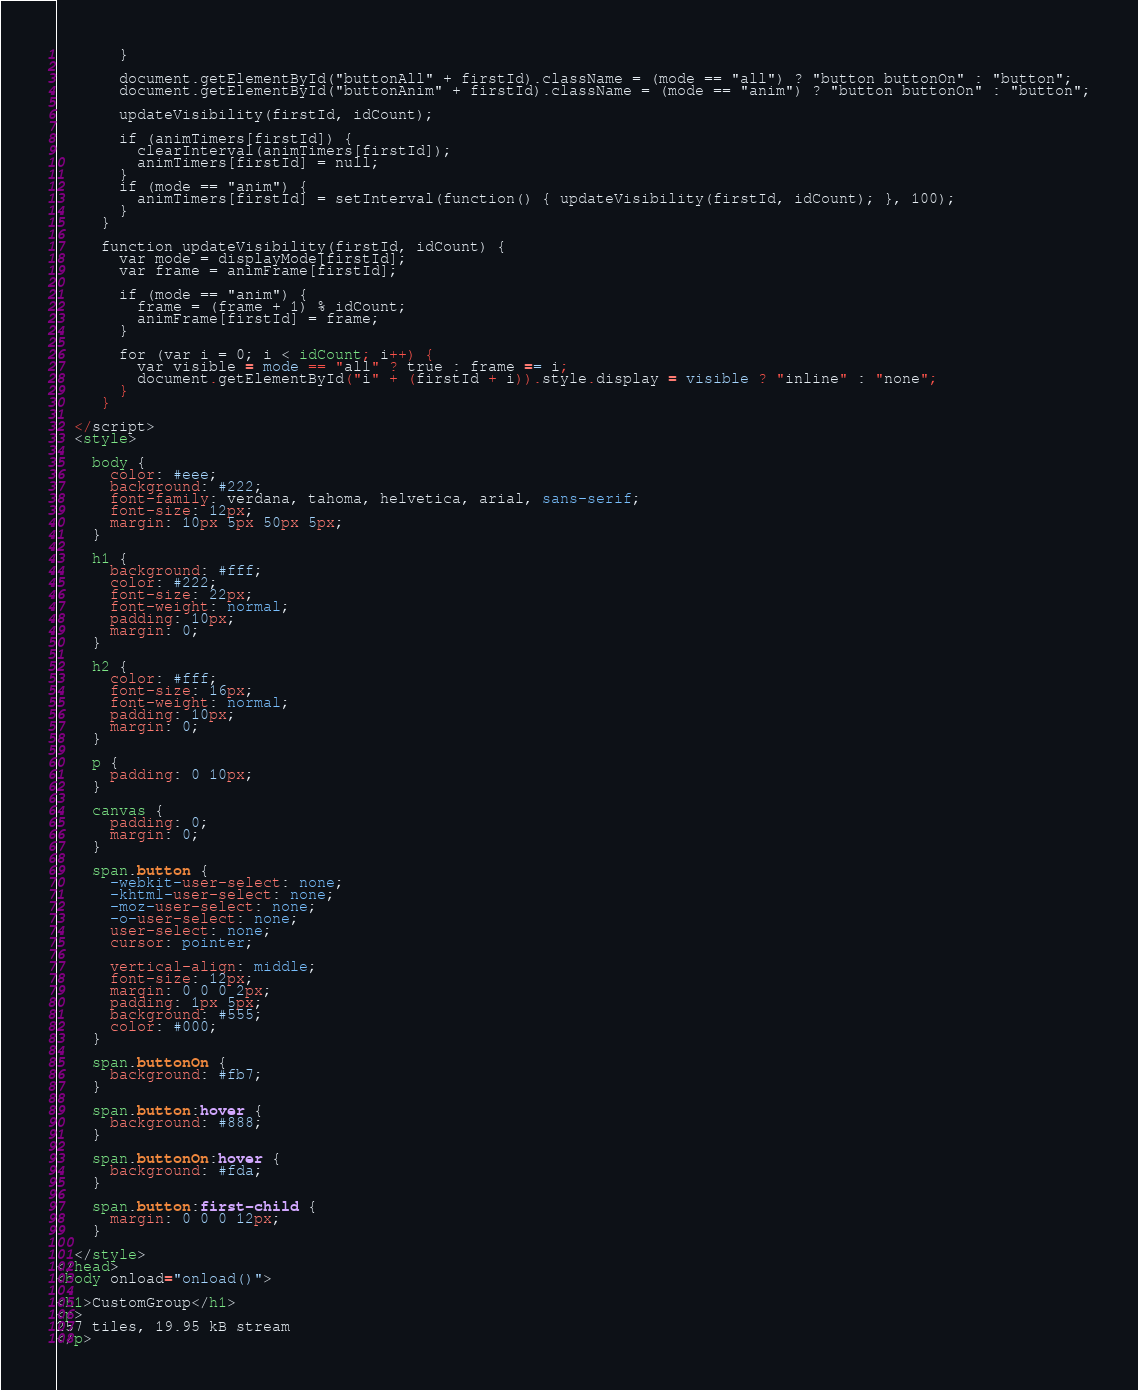Convert code to text. <code><loc_0><loc_0><loc_500><loc_500><_HTML_>       }

       document.getElementById("buttonAll" + firstId).className = (mode == "all") ? "button buttonOn" : "button";
       document.getElementById("buttonAnim" + firstId).className = (mode == "anim") ? "button buttonOn" : "button";

       updateVisibility(firstId, idCount);

       if (animTimers[firstId]) {
         clearInterval(animTimers[firstId]);
         animTimers[firstId] = null;
       }
       if (mode == "anim") {
         animTimers[firstId] = setInterval(function() { updateVisibility(firstId, idCount); }, 100);
       }
     }

     function updateVisibility(firstId, idCount) {
       var mode = displayMode[firstId];
       var frame = animFrame[firstId];

       if (mode == "anim") {
         frame = (frame + 1) % idCount;
         animFrame[firstId] = frame;
       }

       for (var i = 0; i < idCount; i++) {
         var visible = mode == "all" ? true : frame == i;
         document.getElementById("i" + (firstId + i)).style.display = visible ? "inline" : "none";
       }
     }

  </script>
  <style> 
 
    body { 
      color: #eee; 
      background: #222; 
      font-family: verdana, tahoma, helvetica, arial, sans-serif; 
      font-size: 12px; 
      margin: 10px 5px 50px 5px; 
    } 
  
    h1 { 
      background: #fff; 
      color: #222; 
      font-size: 22px; 
      font-weight: normal; 
      padding: 10px; 
      margin: 0; 
    } 
 
    h2 { 
      color: #fff; 
      font-size: 16px; 
      font-weight: normal; 
      padding: 10px; 
      margin: 0; 
    } 
 
    p { 
      padding: 0 10px; 
    } 

    canvas {
      padding: 0;
      margin: 0;
    }

    span.button {
      -webkit-user-select: none;
      -khtml-user-select: none;
      -moz-user-select: none;
      -o-user-select: none;
      user-select: none;
      cursor: pointer;

      vertical-align: middle;
      font-size: 12px; 
      margin: 0 0 0 2px;
      padding: 1px 5px;
      background: #555;
      color: #000;
    }

    span.buttonOn {
      background: #fb7;
    }
 
    span.button:hover {
      background: #888;
    }

    span.buttonOn:hover {
      background: #fda;
    }

    span.button:first-child {
      margin: 0 0 0 12px;
    }

  </style> 
</head> 
<body onload="onload()">

<h1>CustomGroup</h1>
<p>
257 tiles, 19.95 kB stream
</p></code> 